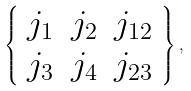Convert formula to latex. <formula><loc_0><loc_0><loc_500><loc_500>\left \{ \begin{array} { c c c } j _ { 1 } & j _ { 2 } & j _ { 1 2 } \\ j _ { 3 } & j _ { 4 } & j _ { 2 3 } \end{array} \right \} ,</formula> 